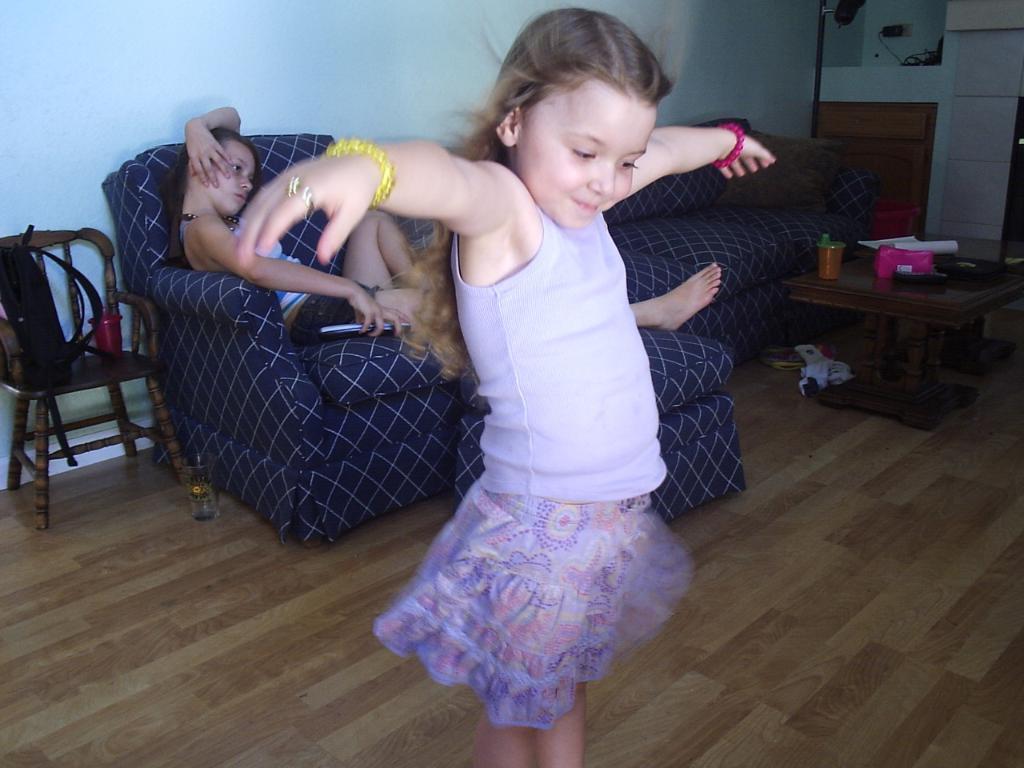Can you describe this image briefly? The image is inside the room. In the image there is a girl standing in middle on left side we can also see a chair, on chair we can see a bag and a bottle. On right side we can see a table,remote,papers and a wall in background there is a white color wall and a girl sitting on couch. 